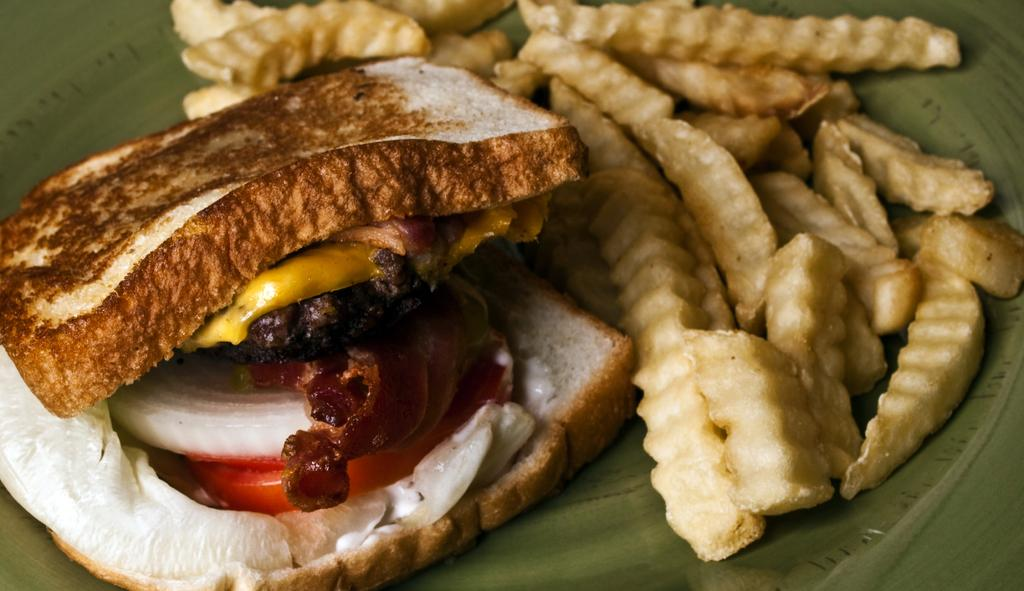What type of food can be seen in the image? There is bread and french fries in the image. Where are the french fries located in the image? The french fries are in a plate in the image. What type of education can be seen in the image? There is no reference to education in the image; it features bread and french fries. How does the bread push the french fries in the image? The bread does not push the french fries in the image; they are separate items in the image. 